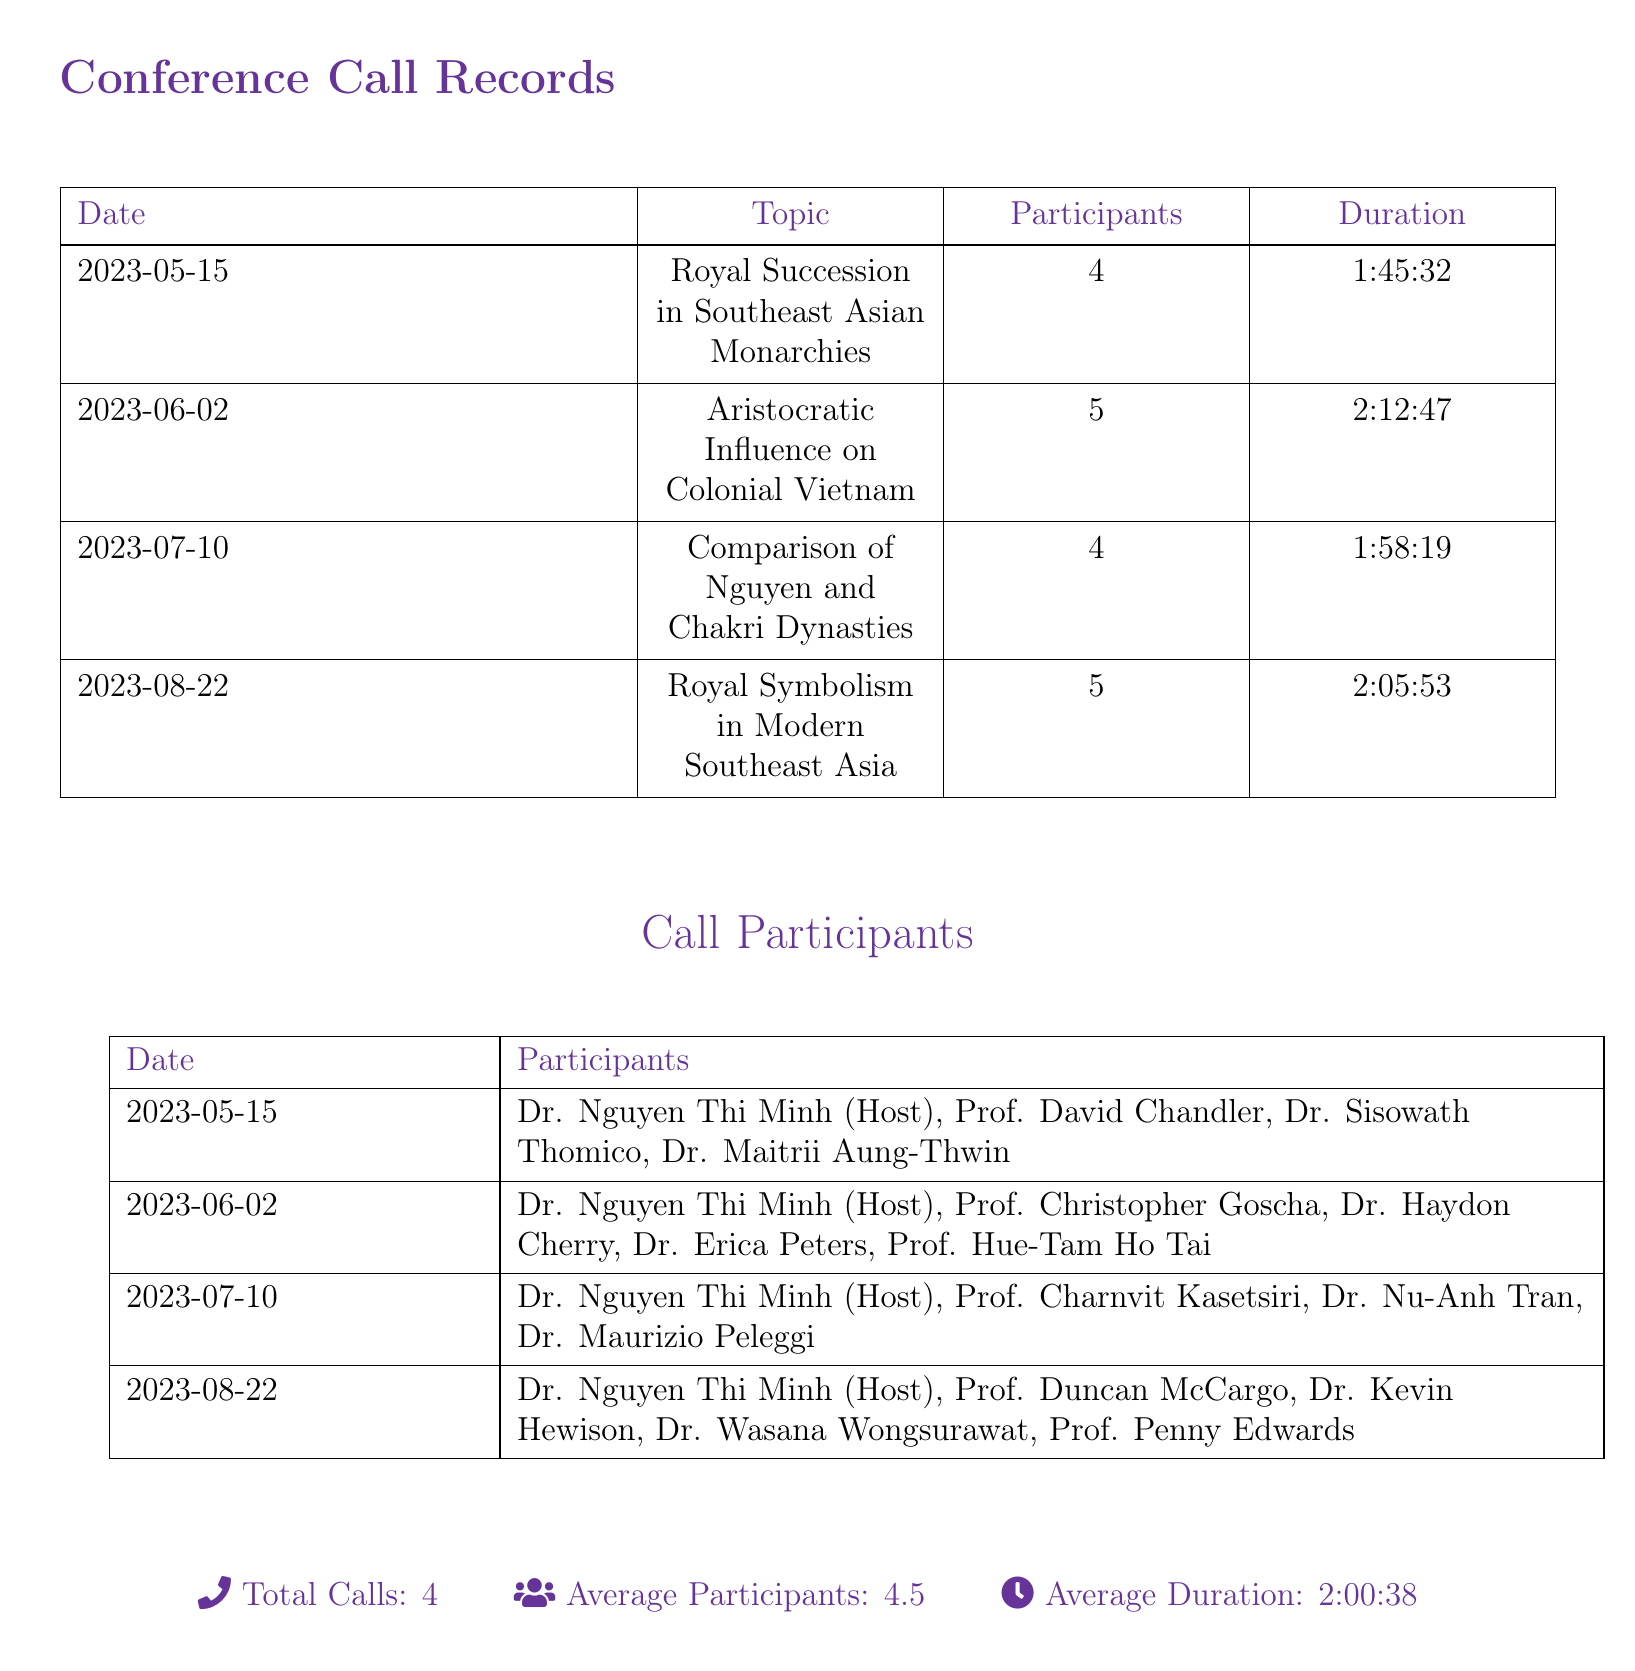What is the date of the call on royal succession? The date of the call is provided in the first row of the conference call records, which is 2023-05-15.
Answer: 2023-05-15 How many participants were there in the call about colonial Vietnam? The number of participants for the call on 2023-06-02 is listed in the corresponding row, which is 5.
Answer: 5 What topic was discussed on July 10, 2023? The topic for the call on this date is indicated in the document, which is Comparison of Nguyen and Chakri Dynasties.
Answer: Comparison of Nguyen and Chakri Dynasties What is the duration of the call on royal symbolism? The duration of the call on August 22, 2023, is provided in the table, which is 2:05:53.
Answer: 2:05:53 How many total calls are recorded in the document? The total number of calls is summarized at the bottom of the document, which states there are 4 calls.
Answer: 4 What is the average number of participants across all calls? The average number of participants is stated in the summary section, which is 4.5.
Answer: 4.5 Which participant hosted all calls? The host for all calls is indicated consistently in the participant list, which is Dr. Nguyen Thi Minh.
Answer: Dr. Nguyen Thi Minh Which call had the longest duration? The duration for each call is compared in the document; the longest is the call on June 2, which lasted 2:12:47.
Answer: 2:12:47 What was the main focus of the call on August 22, 2023? The main focus is described in the topic listed for that date, which is Royal Symbolism in Modern Southeast Asia.
Answer: Royal Symbolism in Modern Southeast Asia 